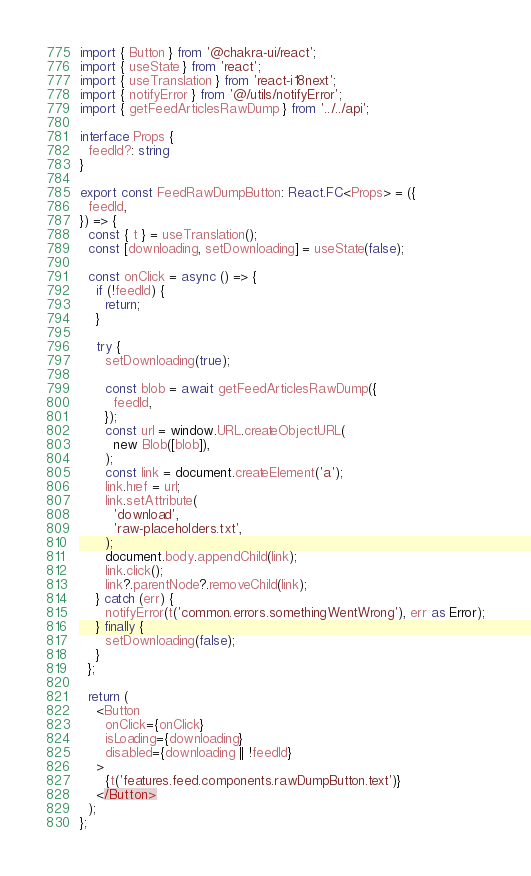<code> <loc_0><loc_0><loc_500><loc_500><_TypeScript_>import { Button } from '@chakra-ui/react';
import { useState } from 'react';
import { useTranslation } from 'react-i18next';
import { notifyError } from '@/utils/notifyError';
import { getFeedArticlesRawDump } from '../../api';

interface Props {
  feedId?: string
}

export const FeedRawDumpButton: React.FC<Props> = ({
  feedId,
}) => {
  const { t } = useTranslation();
  const [downloading, setDownloading] = useState(false);

  const onClick = async () => {
    if (!feedId) {
      return;
    }

    try {
      setDownloading(true);

      const blob = await getFeedArticlesRawDump({
        feedId,
      });
      const url = window.URL.createObjectURL(
        new Blob([blob]),
      );
      const link = document.createElement('a');
      link.href = url;
      link.setAttribute(
        'download',
        'raw-placeholders.txt',
      );
      document.body.appendChild(link);
      link.click();
      link?.parentNode?.removeChild(link);
    } catch (err) {
      notifyError(t('common.errors.somethingWentWrong'), err as Error);
    } finally {
      setDownloading(false);
    }
  };

  return (
    <Button
      onClick={onClick}
      isLoading={downloading}
      disabled={downloading || !feedId}
    >
      {t('features.feed.components.rawDumpButton.text')}
    </Button>
  );
};
</code> 